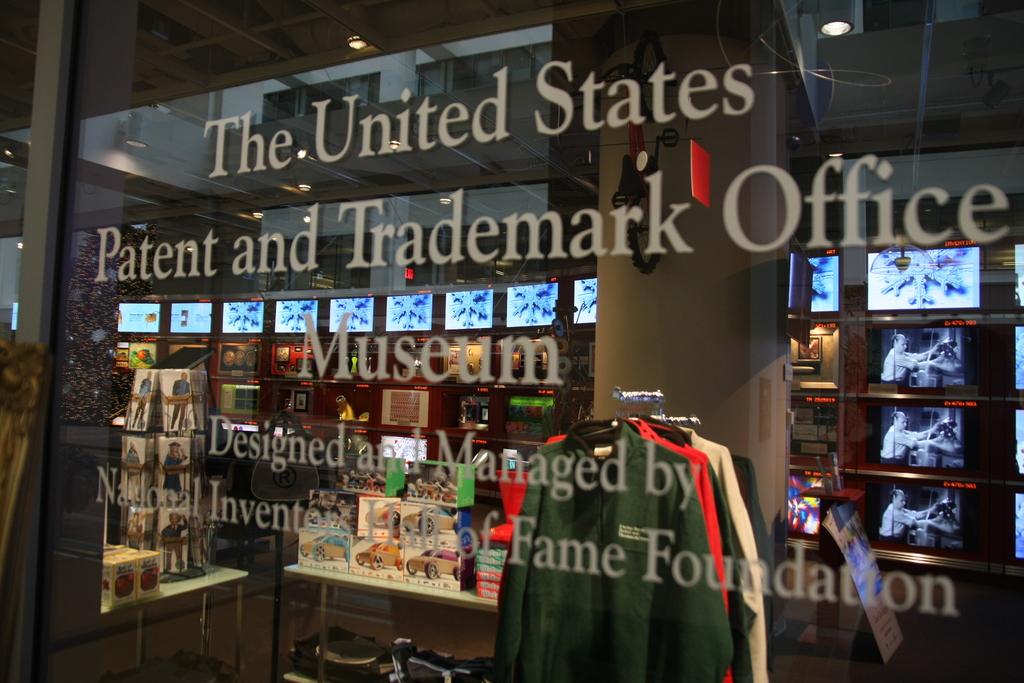What office is this museum dedicated to?
Offer a very short reply. Us patent and trademark office. What country is this museum for?
Your answer should be compact. United states. 